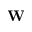<formula> <loc_0><loc_0><loc_500><loc_500>W</formula> 